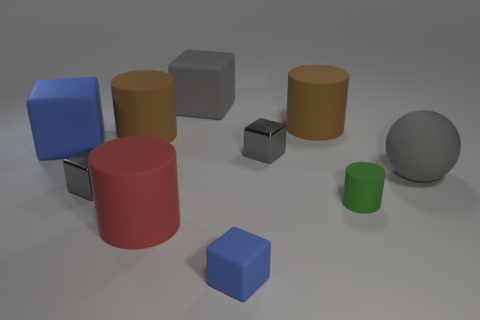How many gray cubes must be subtracted to get 1 gray cubes? 2 Subtract all big red rubber cylinders. How many cylinders are left? 3 Subtract all blue cylinders. How many gray blocks are left? 3 Subtract all green cylinders. How many cylinders are left? 3 Subtract 2 cubes. How many cubes are left? 3 Subtract all purple blocks. Subtract all red cylinders. How many blocks are left? 5 Subtract all spheres. How many objects are left? 9 Subtract 0 green cubes. How many objects are left? 10 Subtract all big brown balls. Subtract all gray rubber cubes. How many objects are left? 9 Add 9 small cylinders. How many small cylinders are left? 10 